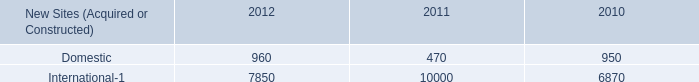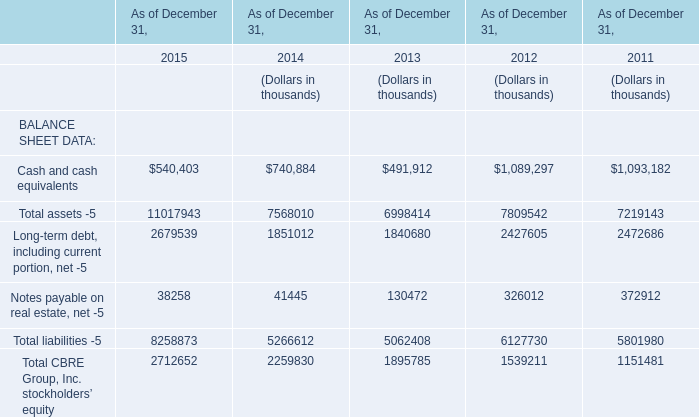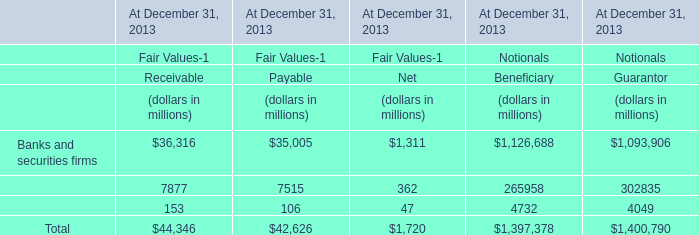What is the sum of the Notes payable on real estate, net -5 in the years / sections where Cash and cash equivalents is positive? (in thousand) 
Computations: ((((38258 + 41445) + 130472) + 326012) + 372912)
Answer: 909099.0. 